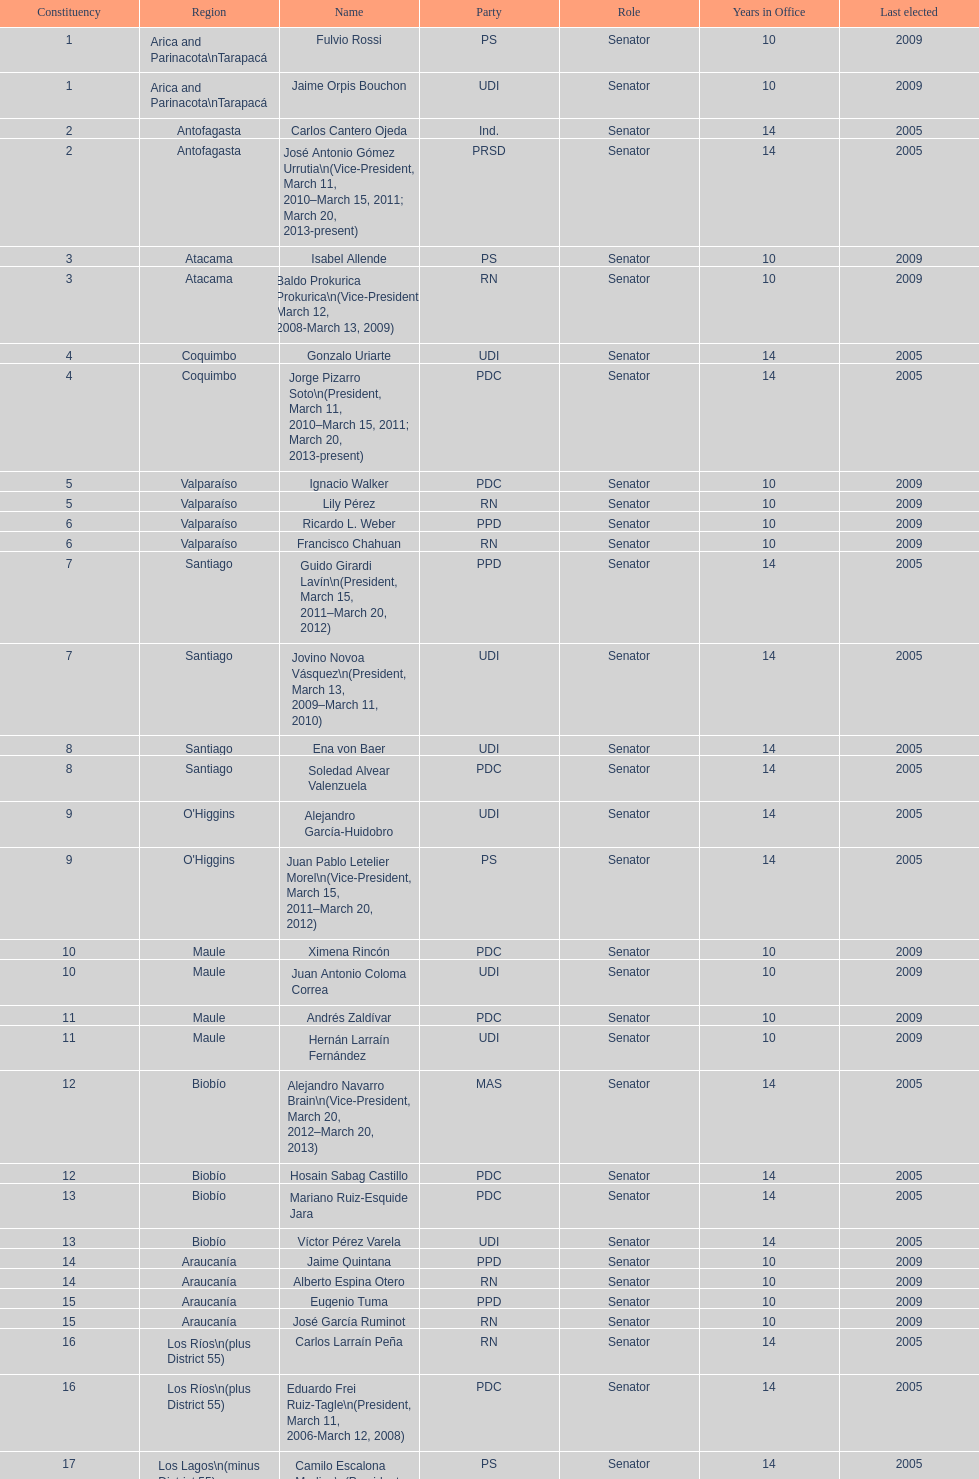What is the first name on the table? Fulvio Rossi. 